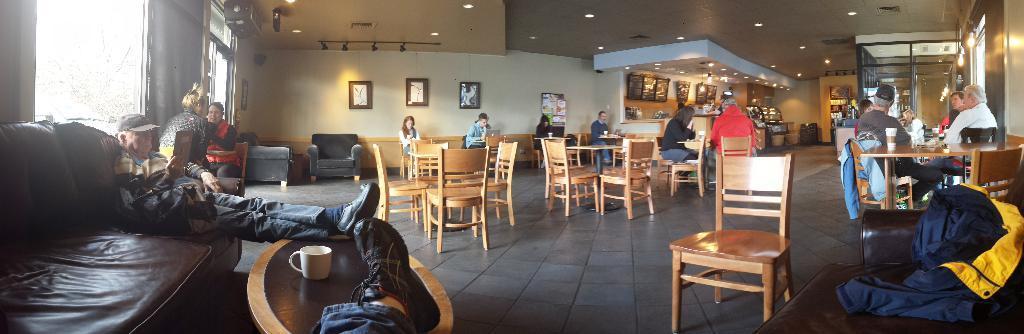Could you give a brief overview of what you see in this image? In the image we can see there are people who are sitting on chair and a man is sitting on sofa, he is leaning his leg on the table. 